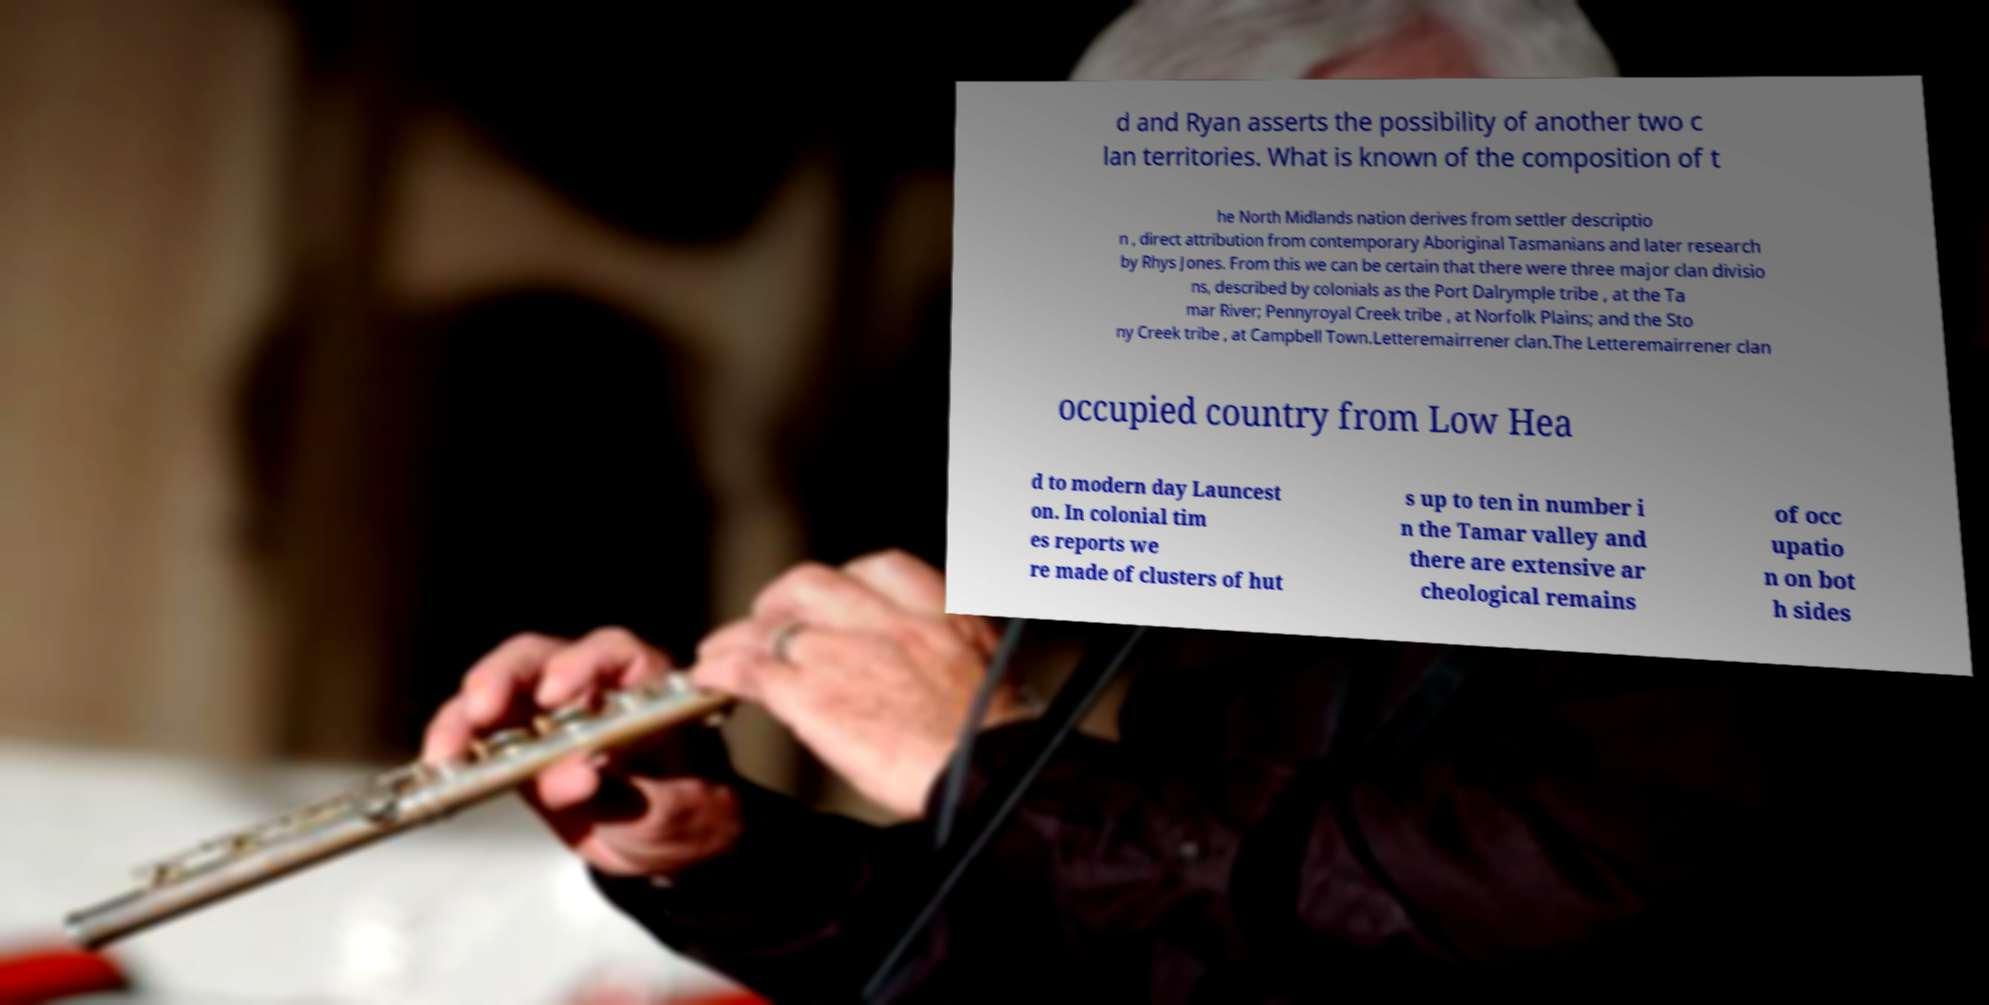Could you assist in decoding the text presented in this image and type it out clearly? d and Ryan asserts the possibility of another two c lan territories. What is known of the composition of t he North Midlands nation derives from settler descriptio n , direct attribution from contemporary Aboriginal Tasmanians and later research by Rhys Jones. From this we can be certain that there were three major clan divisio ns, described by colonials as the Port Dalrymple tribe , at the Ta mar River; Pennyroyal Creek tribe , at Norfolk Plains; and the Sto ny Creek tribe , at Campbell Town.Letteremairrener clan.The Letteremairrener clan occupied country from Low Hea d to modern day Launcest on. In colonial tim es reports we re made of clusters of hut s up to ten in number i n the Tamar valley and there are extensive ar cheological remains of occ upatio n on bot h sides 